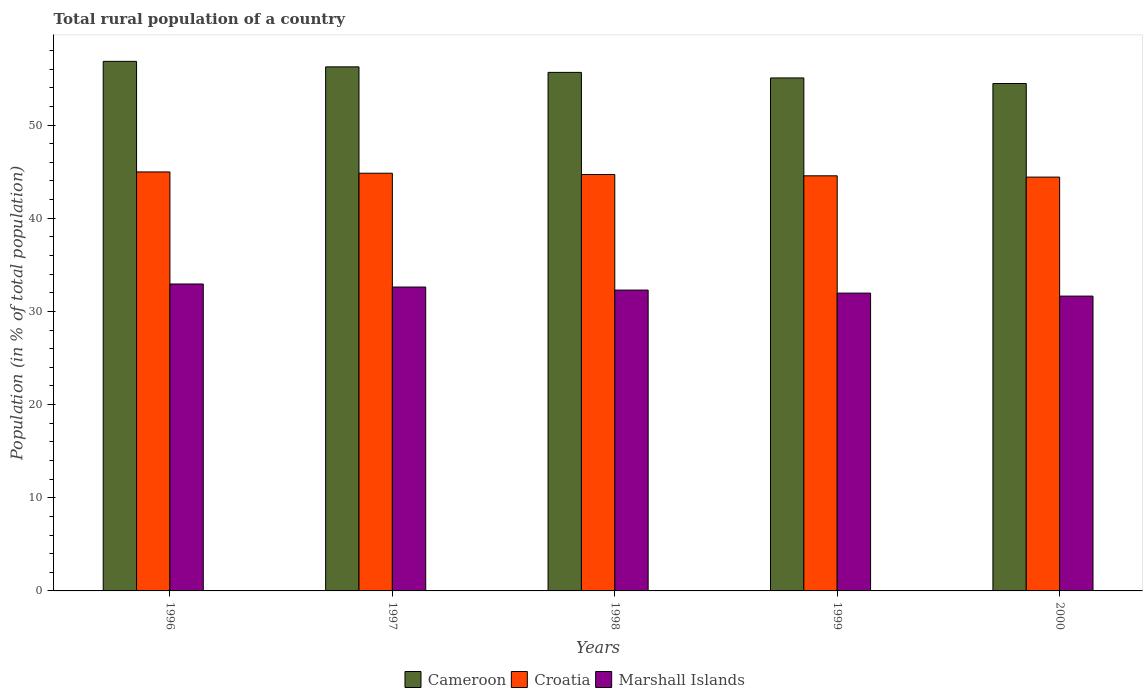How many groups of bars are there?
Offer a very short reply. 5. Are the number of bars on each tick of the X-axis equal?
Offer a very short reply. Yes. How many bars are there on the 3rd tick from the right?
Offer a terse response. 3. What is the label of the 1st group of bars from the left?
Provide a succinct answer. 1996. What is the rural population in Marshall Islands in 1999?
Your answer should be compact. 31.96. Across all years, what is the maximum rural population in Cameroon?
Keep it short and to the point. 56.84. Across all years, what is the minimum rural population in Cameroon?
Give a very brief answer. 54.46. What is the total rural population in Marshall Islands in the graph?
Keep it short and to the point. 161.45. What is the difference between the rural population in Croatia in 1996 and that in 2000?
Ensure brevity in your answer.  0.56. What is the difference between the rural population in Croatia in 1996 and the rural population in Marshall Islands in 1999?
Your answer should be very brief. 13.01. What is the average rural population in Croatia per year?
Your response must be concise. 44.69. In the year 1999, what is the difference between the rural population in Marshall Islands and rural population in Cameroon?
Provide a succinct answer. -23.09. In how many years, is the rural population in Marshall Islands greater than 18 %?
Ensure brevity in your answer.  5. What is the ratio of the rural population in Cameroon in 1996 to that in 1998?
Your response must be concise. 1.02. Is the difference between the rural population in Marshall Islands in 1997 and 1998 greater than the difference between the rural population in Cameroon in 1997 and 1998?
Provide a short and direct response. No. What is the difference between the highest and the second highest rural population in Croatia?
Your answer should be very brief. 0.14. What is the difference between the highest and the lowest rural population in Cameroon?
Your response must be concise. 2.38. In how many years, is the rural population in Croatia greater than the average rural population in Croatia taken over all years?
Offer a terse response. 3. What does the 2nd bar from the left in 1997 represents?
Offer a terse response. Croatia. What does the 1st bar from the right in 1999 represents?
Keep it short and to the point. Marshall Islands. How many years are there in the graph?
Give a very brief answer. 5. How are the legend labels stacked?
Provide a succinct answer. Horizontal. What is the title of the graph?
Give a very brief answer. Total rural population of a country. What is the label or title of the X-axis?
Your answer should be very brief. Years. What is the label or title of the Y-axis?
Ensure brevity in your answer.  Population (in % of total population). What is the Population (in % of total population) of Cameroon in 1996?
Your response must be concise. 56.84. What is the Population (in % of total population) in Croatia in 1996?
Make the answer very short. 44.97. What is the Population (in % of total population) of Marshall Islands in 1996?
Offer a very short reply. 32.94. What is the Population (in % of total population) of Cameroon in 1997?
Provide a succinct answer. 56.24. What is the Population (in % of total population) of Croatia in 1997?
Your answer should be compact. 44.83. What is the Population (in % of total population) in Marshall Islands in 1997?
Ensure brevity in your answer.  32.62. What is the Population (in % of total population) of Cameroon in 1998?
Provide a succinct answer. 55.65. What is the Population (in % of total population) of Croatia in 1998?
Your answer should be very brief. 44.69. What is the Population (in % of total population) in Marshall Islands in 1998?
Offer a very short reply. 32.29. What is the Population (in % of total population) in Cameroon in 1999?
Offer a very short reply. 55.06. What is the Population (in % of total population) in Croatia in 1999?
Make the answer very short. 44.55. What is the Population (in % of total population) of Marshall Islands in 1999?
Your answer should be compact. 31.96. What is the Population (in % of total population) in Cameroon in 2000?
Offer a very short reply. 54.46. What is the Population (in % of total population) in Croatia in 2000?
Your answer should be very brief. 44.41. What is the Population (in % of total population) in Marshall Islands in 2000?
Offer a terse response. 31.64. Across all years, what is the maximum Population (in % of total population) of Cameroon?
Ensure brevity in your answer.  56.84. Across all years, what is the maximum Population (in % of total population) in Croatia?
Make the answer very short. 44.97. Across all years, what is the maximum Population (in % of total population) in Marshall Islands?
Provide a succinct answer. 32.94. Across all years, what is the minimum Population (in % of total population) in Cameroon?
Provide a short and direct response. 54.46. Across all years, what is the minimum Population (in % of total population) of Croatia?
Your response must be concise. 44.41. Across all years, what is the minimum Population (in % of total population) of Marshall Islands?
Your response must be concise. 31.64. What is the total Population (in % of total population) in Cameroon in the graph?
Offer a very short reply. 278.25. What is the total Population (in % of total population) in Croatia in the graph?
Offer a very short reply. 223.46. What is the total Population (in % of total population) in Marshall Islands in the graph?
Provide a succinct answer. 161.45. What is the difference between the Population (in % of total population) in Cameroon in 1996 and that in 1997?
Provide a succinct answer. 0.59. What is the difference between the Population (in % of total population) in Croatia in 1996 and that in 1997?
Offer a very short reply. 0.14. What is the difference between the Population (in % of total population) in Marshall Islands in 1996 and that in 1997?
Keep it short and to the point. 0.33. What is the difference between the Population (in % of total population) of Cameroon in 1996 and that in 1998?
Offer a very short reply. 1.18. What is the difference between the Population (in % of total population) in Croatia in 1996 and that in 1998?
Offer a very short reply. 0.28. What is the difference between the Population (in % of total population) of Marshall Islands in 1996 and that in 1998?
Offer a terse response. 0.65. What is the difference between the Population (in % of total population) in Cameroon in 1996 and that in 1999?
Provide a succinct answer. 1.78. What is the difference between the Population (in % of total population) in Croatia in 1996 and that in 1999?
Your answer should be compact. 0.42. What is the difference between the Population (in % of total population) of Cameroon in 1996 and that in 2000?
Offer a very short reply. 2.38. What is the difference between the Population (in % of total population) in Croatia in 1996 and that in 2000?
Offer a terse response. 0.56. What is the difference between the Population (in % of total population) in Marshall Islands in 1996 and that in 2000?
Give a very brief answer. 1.3. What is the difference between the Population (in % of total population) of Cameroon in 1997 and that in 1998?
Ensure brevity in your answer.  0.59. What is the difference between the Population (in % of total population) of Croatia in 1997 and that in 1998?
Your response must be concise. 0.14. What is the difference between the Population (in % of total population) in Marshall Islands in 1997 and that in 1998?
Make the answer very short. 0.33. What is the difference between the Population (in % of total population) in Cameroon in 1997 and that in 1999?
Your answer should be very brief. 1.19. What is the difference between the Population (in % of total population) of Croatia in 1997 and that in 1999?
Give a very brief answer. 0.28. What is the difference between the Population (in % of total population) of Marshall Islands in 1997 and that in 1999?
Your answer should be compact. 0.65. What is the difference between the Population (in % of total population) of Cameroon in 1997 and that in 2000?
Offer a very short reply. 1.79. What is the difference between the Population (in % of total population) of Croatia in 1997 and that in 2000?
Keep it short and to the point. 0.42. What is the difference between the Population (in % of total population) of Marshall Islands in 1997 and that in 2000?
Your response must be concise. 0.97. What is the difference between the Population (in % of total population) of Cameroon in 1998 and that in 1999?
Offer a terse response. 0.6. What is the difference between the Population (in % of total population) in Croatia in 1998 and that in 1999?
Make the answer very short. 0.14. What is the difference between the Population (in % of total population) in Marshall Islands in 1998 and that in 1999?
Your response must be concise. 0.33. What is the difference between the Population (in % of total population) in Cameroon in 1998 and that in 2000?
Your answer should be very brief. 1.19. What is the difference between the Population (in % of total population) of Croatia in 1998 and that in 2000?
Give a very brief answer. 0.28. What is the difference between the Population (in % of total population) of Marshall Islands in 1998 and that in 2000?
Provide a succinct answer. 0.65. What is the difference between the Population (in % of total population) in Cameroon in 1999 and that in 2000?
Give a very brief answer. 0.6. What is the difference between the Population (in % of total population) in Croatia in 1999 and that in 2000?
Offer a terse response. 0.14. What is the difference between the Population (in % of total population) in Marshall Islands in 1999 and that in 2000?
Make the answer very short. 0.32. What is the difference between the Population (in % of total population) in Cameroon in 1996 and the Population (in % of total population) in Croatia in 1997?
Offer a very short reply. 12.01. What is the difference between the Population (in % of total population) in Cameroon in 1996 and the Population (in % of total population) in Marshall Islands in 1997?
Your answer should be compact. 24.22. What is the difference between the Population (in % of total population) in Croatia in 1996 and the Population (in % of total population) in Marshall Islands in 1997?
Ensure brevity in your answer.  12.35. What is the difference between the Population (in % of total population) in Cameroon in 1996 and the Population (in % of total population) in Croatia in 1998?
Your response must be concise. 12.14. What is the difference between the Population (in % of total population) in Cameroon in 1996 and the Population (in % of total population) in Marshall Islands in 1998?
Offer a very short reply. 24.55. What is the difference between the Population (in % of total population) in Croatia in 1996 and the Population (in % of total population) in Marshall Islands in 1998?
Ensure brevity in your answer.  12.68. What is the difference between the Population (in % of total population) of Cameroon in 1996 and the Population (in % of total population) of Croatia in 1999?
Make the answer very short. 12.28. What is the difference between the Population (in % of total population) of Cameroon in 1996 and the Population (in % of total population) of Marshall Islands in 1999?
Make the answer very short. 24.87. What is the difference between the Population (in % of total population) of Croatia in 1996 and the Population (in % of total population) of Marshall Islands in 1999?
Your answer should be compact. 13.01. What is the difference between the Population (in % of total population) in Cameroon in 1996 and the Population (in % of total population) in Croatia in 2000?
Offer a terse response. 12.42. What is the difference between the Population (in % of total population) in Cameroon in 1996 and the Population (in % of total population) in Marshall Islands in 2000?
Ensure brevity in your answer.  25.19. What is the difference between the Population (in % of total population) of Croatia in 1996 and the Population (in % of total population) of Marshall Islands in 2000?
Make the answer very short. 13.33. What is the difference between the Population (in % of total population) in Cameroon in 1997 and the Population (in % of total population) in Croatia in 1998?
Offer a terse response. 11.55. What is the difference between the Population (in % of total population) of Cameroon in 1997 and the Population (in % of total population) of Marshall Islands in 1998?
Offer a very short reply. 23.96. What is the difference between the Population (in % of total population) of Croatia in 1997 and the Population (in % of total population) of Marshall Islands in 1998?
Your answer should be compact. 12.54. What is the difference between the Population (in % of total population) in Cameroon in 1997 and the Population (in % of total population) in Croatia in 1999?
Give a very brief answer. 11.69. What is the difference between the Population (in % of total population) of Cameroon in 1997 and the Population (in % of total population) of Marshall Islands in 1999?
Ensure brevity in your answer.  24.28. What is the difference between the Population (in % of total population) of Croatia in 1997 and the Population (in % of total population) of Marshall Islands in 1999?
Provide a short and direct response. 12.87. What is the difference between the Population (in % of total population) of Cameroon in 1997 and the Population (in % of total population) of Croatia in 2000?
Your response must be concise. 11.83. What is the difference between the Population (in % of total population) of Cameroon in 1997 and the Population (in % of total population) of Marshall Islands in 2000?
Give a very brief answer. 24.6. What is the difference between the Population (in % of total population) of Croatia in 1997 and the Population (in % of total population) of Marshall Islands in 2000?
Keep it short and to the point. 13.19. What is the difference between the Population (in % of total population) of Cameroon in 1998 and the Population (in % of total population) of Croatia in 1999?
Keep it short and to the point. 11.1. What is the difference between the Population (in % of total population) of Cameroon in 1998 and the Population (in % of total population) of Marshall Islands in 1999?
Your answer should be compact. 23.69. What is the difference between the Population (in % of total population) in Croatia in 1998 and the Population (in % of total population) in Marshall Islands in 1999?
Provide a short and direct response. 12.73. What is the difference between the Population (in % of total population) in Cameroon in 1998 and the Population (in % of total population) in Croatia in 2000?
Your answer should be very brief. 11.24. What is the difference between the Population (in % of total population) of Cameroon in 1998 and the Population (in % of total population) of Marshall Islands in 2000?
Your answer should be compact. 24.01. What is the difference between the Population (in % of total population) in Croatia in 1998 and the Population (in % of total population) in Marshall Islands in 2000?
Offer a very short reply. 13.05. What is the difference between the Population (in % of total population) in Cameroon in 1999 and the Population (in % of total population) in Croatia in 2000?
Your answer should be compact. 10.64. What is the difference between the Population (in % of total population) of Cameroon in 1999 and the Population (in % of total population) of Marshall Islands in 2000?
Offer a terse response. 23.41. What is the difference between the Population (in % of total population) in Croatia in 1999 and the Population (in % of total population) in Marshall Islands in 2000?
Your response must be concise. 12.91. What is the average Population (in % of total population) of Cameroon per year?
Provide a succinct answer. 55.65. What is the average Population (in % of total population) in Croatia per year?
Provide a succinct answer. 44.69. What is the average Population (in % of total population) in Marshall Islands per year?
Your answer should be very brief. 32.29. In the year 1996, what is the difference between the Population (in % of total population) of Cameroon and Population (in % of total population) of Croatia?
Your answer should be compact. 11.87. In the year 1996, what is the difference between the Population (in % of total population) of Cameroon and Population (in % of total population) of Marshall Islands?
Keep it short and to the point. 23.89. In the year 1996, what is the difference between the Population (in % of total population) of Croatia and Population (in % of total population) of Marshall Islands?
Your answer should be compact. 12.03. In the year 1997, what is the difference between the Population (in % of total population) in Cameroon and Population (in % of total population) in Croatia?
Give a very brief answer. 11.41. In the year 1997, what is the difference between the Population (in % of total population) in Cameroon and Population (in % of total population) in Marshall Islands?
Keep it short and to the point. 23.63. In the year 1997, what is the difference between the Population (in % of total population) of Croatia and Population (in % of total population) of Marshall Islands?
Ensure brevity in your answer.  12.21. In the year 1998, what is the difference between the Population (in % of total population) of Cameroon and Population (in % of total population) of Croatia?
Give a very brief answer. 10.96. In the year 1998, what is the difference between the Population (in % of total population) in Cameroon and Population (in % of total population) in Marshall Islands?
Offer a terse response. 23.36. In the year 1998, what is the difference between the Population (in % of total population) of Croatia and Population (in % of total population) of Marshall Islands?
Offer a terse response. 12.4. In the year 1999, what is the difference between the Population (in % of total population) of Cameroon and Population (in % of total population) of Croatia?
Give a very brief answer. 10.5. In the year 1999, what is the difference between the Population (in % of total population) of Cameroon and Population (in % of total population) of Marshall Islands?
Give a very brief answer. 23.09. In the year 1999, what is the difference between the Population (in % of total population) of Croatia and Population (in % of total population) of Marshall Islands?
Provide a short and direct response. 12.59. In the year 2000, what is the difference between the Population (in % of total population) in Cameroon and Population (in % of total population) in Croatia?
Give a very brief answer. 10.04. In the year 2000, what is the difference between the Population (in % of total population) in Cameroon and Population (in % of total population) in Marshall Islands?
Your answer should be compact. 22.82. In the year 2000, what is the difference between the Population (in % of total population) in Croatia and Population (in % of total population) in Marshall Islands?
Your answer should be compact. 12.77. What is the ratio of the Population (in % of total population) in Cameroon in 1996 to that in 1997?
Your answer should be very brief. 1.01. What is the ratio of the Population (in % of total population) of Croatia in 1996 to that in 1997?
Provide a succinct answer. 1. What is the ratio of the Population (in % of total population) of Marshall Islands in 1996 to that in 1997?
Make the answer very short. 1.01. What is the ratio of the Population (in % of total population) of Cameroon in 1996 to that in 1998?
Ensure brevity in your answer.  1.02. What is the ratio of the Population (in % of total population) of Marshall Islands in 1996 to that in 1998?
Your response must be concise. 1.02. What is the ratio of the Population (in % of total population) in Cameroon in 1996 to that in 1999?
Make the answer very short. 1.03. What is the ratio of the Population (in % of total population) of Croatia in 1996 to that in 1999?
Your answer should be compact. 1.01. What is the ratio of the Population (in % of total population) in Marshall Islands in 1996 to that in 1999?
Provide a succinct answer. 1.03. What is the ratio of the Population (in % of total population) of Cameroon in 1996 to that in 2000?
Offer a very short reply. 1.04. What is the ratio of the Population (in % of total population) in Croatia in 1996 to that in 2000?
Ensure brevity in your answer.  1.01. What is the ratio of the Population (in % of total population) in Marshall Islands in 1996 to that in 2000?
Your response must be concise. 1.04. What is the ratio of the Population (in % of total population) of Cameroon in 1997 to that in 1998?
Make the answer very short. 1.01. What is the ratio of the Population (in % of total population) in Croatia in 1997 to that in 1998?
Provide a succinct answer. 1. What is the ratio of the Population (in % of total population) of Cameroon in 1997 to that in 1999?
Give a very brief answer. 1.02. What is the ratio of the Population (in % of total population) in Croatia in 1997 to that in 1999?
Offer a very short reply. 1.01. What is the ratio of the Population (in % of total population) of Marshall Islands in 1997 to that in 1999?
Provide a succinct answer. 1.02. What is the ratio of the Population (in % of total population) of Cameroon in 1997 to that in 2000?
Offer a terse response. 1.03. What is the ratio of the Population (in % of total population) in Croatia in 1997 to that in 2000?
Provide a succinct answer. 1.01. What is the ratio of the Population (in % of total population) of Marshall Islands in 1997 to that in 2000?
Your answer should be compact. 1.03. What is the ratio of the Population (in % of total population) of Cameroon in 1998 to that in 1999?
Provide a succinct answer. 1.01. What is the ratio of the Population (in % of total population) of Marshall Islands in 1998 to that in 1999?
Keep it short and to the point. 1.01. What is the ratio of the Population (in % of total population) of Cameroon in 1998 to that in 2000?
Make the answer very short. 1.02. What is the ratio of the Population (in % of total population) in Marshall Islands in 1998 to that in 2000?
Keep it short and to the point. 1.02. What is the ratio of the Population (in % of total population) of Cameroon in 1999 to that in 2000?
Your answer should be very brief. 1.01. What is the ratio of the Population (in % of total population) of Croatia in 1999 to that in 2000?
Keep it short and to the point. 1. What is the ratio of the Population (in % of total population) in Marshall Islands in 1999 to that in 2000?
Your answer should be very brief. 1.01. What is the difference between the highest and the second highest Population (in % of total population) of Cameroon?
Keep it short and to the point. 0.59. What is the difference between the highest and the second highest Population (in % of total population) of Croatia?
Provide a succinct answer. 0.14. What is the difference between the highest and the second highest Population (in % of total population) in Marshall Islands?
Ensure brevity in your answer.  0.33. What is the difference between the highest and the lowest Population (in % of total population) in Cameroon?
Ensure brevity in your answer.  2.38. What is the difference between the highest and the lowest Population (in % of total population) in Croatia?
Your answer should be compact. 0.56. What is the difference between the highest and the lowest Population (in % of total population) in Marshall Islands?
Ensure brevity in your answer.  1.3. 